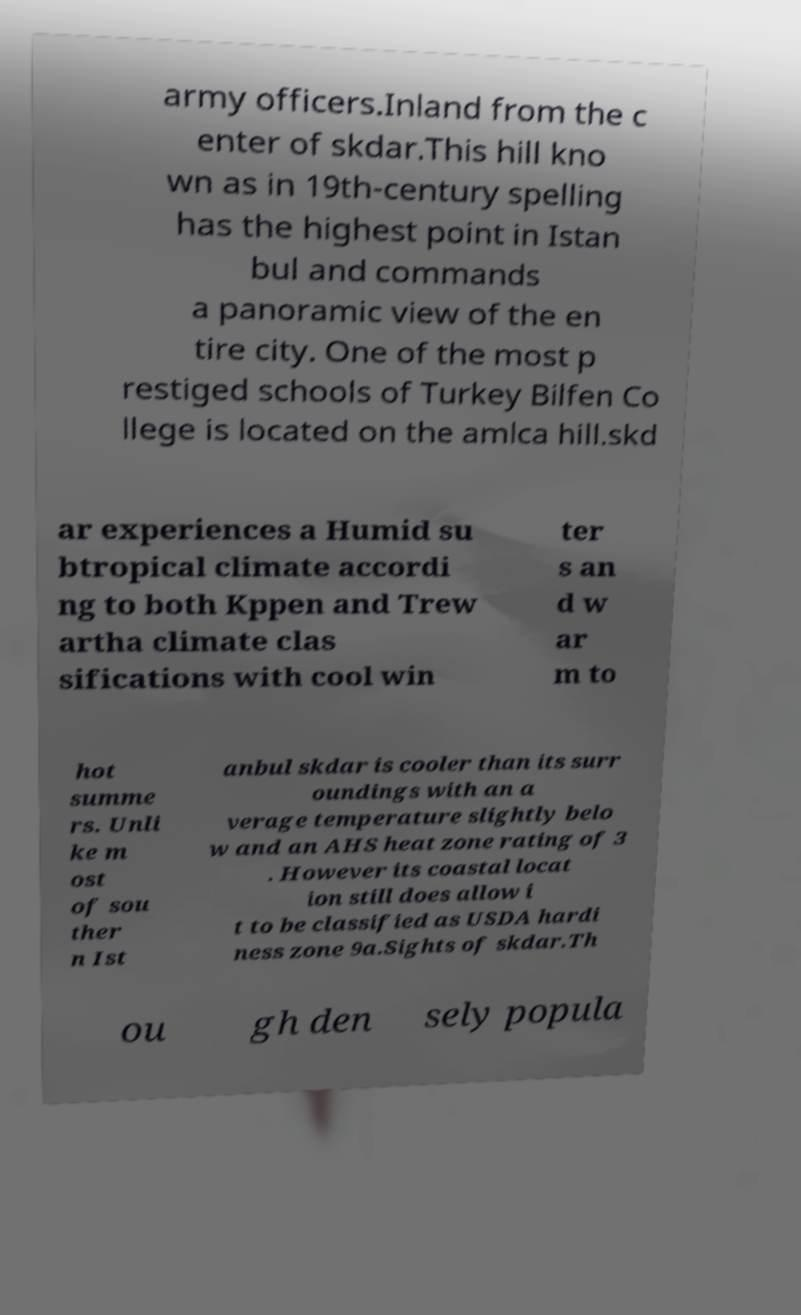Please read and relay the text visible in this image. What does it say? army officers.Inland from the c enter of skdar.This hill kno wn as in 19th-century spelling has the highest point in Istan bul and commands a panoramic view of the en tire city. One of the most p restiged schools of Turkey Bilfen Co llege is located on the amlca hill.skd ar experiences a Humid su btropical climate accordi ng to both Kppen and Trew artha climate clas sifications with cool win ter s an d w ar m to hot summe rs. Unli ke m ost of sou ther n Ist anbul skdar is cooler than its surr oundings with an a verage temperature slightly belo w and an AHS heat zone rating of 3 . However its coastal locat ion still does allow i t to be classified as USDA hardi ness zone 9a.Sights of skdar.Th ou gh den sely popula 